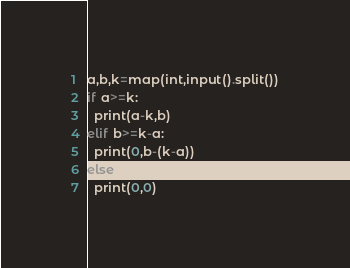<code> <loc_0><loc_0><loc_500><loc_500><_Python_>a,b,k=map(int,input().split())
if a>=k:
  print(a-k,b)
elif b>=k-a:
  print(0,b-(k-a))
else:
  print(0,0)
</code> 